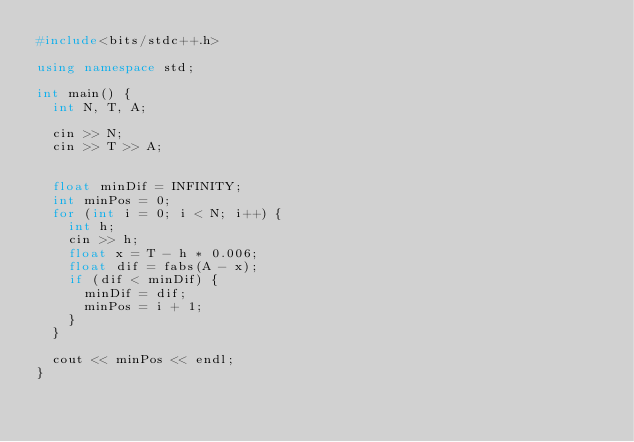Convert code to text. <code><loc_0><loc_0><loc_500><loc_500><_C++_>#include<bits/stdc++.h>

using namespace std;

int main() {
	int N, T, A;

	cin >> N;
	cin >> T >> A;


	float minDif = INFINITY;
	int minPos = 0;
	for (int i = 0; i < N; i++) {
		int h;
		cin >> h;
		float x = T - h * 0.006;
		float dif = fabs(A - x);
		if (dif < minDif) {
			minDif = dif;
			minPos = i + 1;
		}
	}

	cout << minPos << endl;
}
</code> 